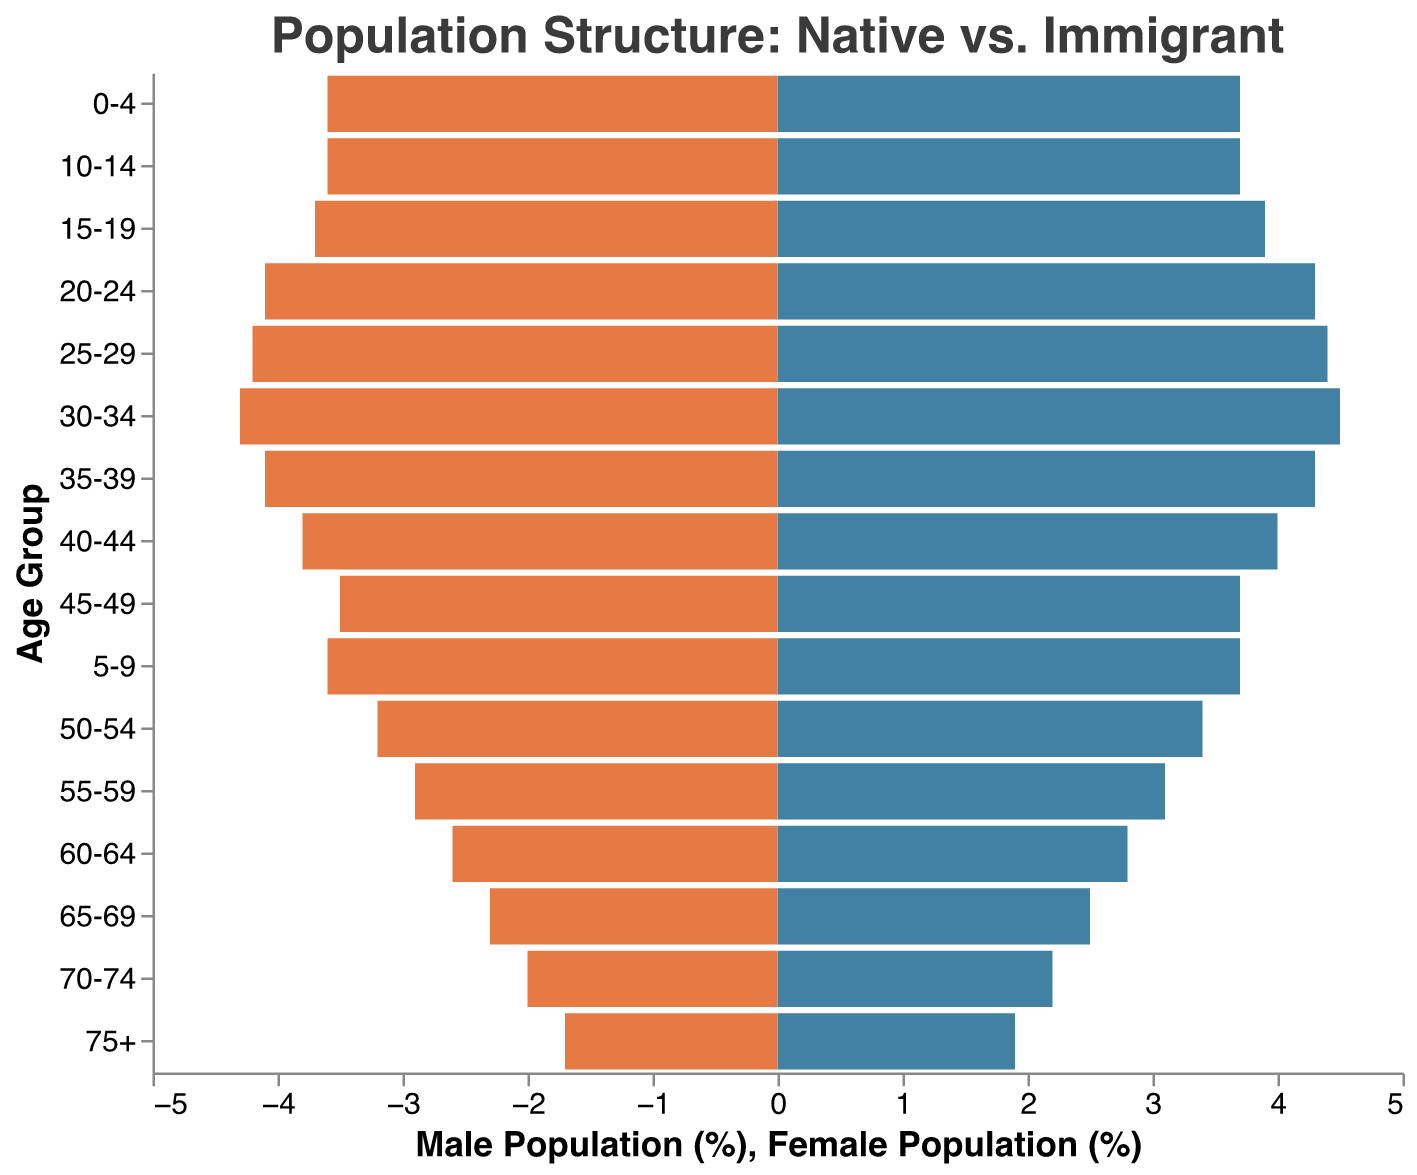what's the title of the figure? The title of the figure is displayed at the top of the plot in a larger font. It reads "Population Structure: Native vs. Immigrant".
Answer: Population Structure: Native vs. Immigrant what is the age group with the highest proportion of native males? By observing the bars on the left for native males, the group with the largest bar is labeled "0-4". The height is roughly 3.2%.
Answer: 0-4 which age group has the smallest proportion of immigrant females? Among the bars on the left for immigrant females, the group with the smallest bar is labeled "75+". The height is roughly 0.5%.
Answer: 75+ what's the combined size of the 30-34 age group (native female + immigrant female)? From the figure's data, the native female percentage for 30-34 is 2.1%, and the immigrant female percentage is 2.2%. Adding them produces 2.1 + 2.2 = 4.3%.
Answer: 4.3% is the population of immigrants aged 20-24 greater than that of the 40-44 age group? The bars for immigrants aged 20-24 (both male and female) sum up to 1.8% (male) + 1.7% (female) = 3.5%. Meanwhile, the bars for immigrants aged 40-44 sum up to 2.0% (male) + 1.9% (female) = 3.9%. 3.5% is less than 3.9%.
Answer: No which age group has a greater male proportion compared to female: native or immigrant? For each age category, comparing native and immigrant populations: 
- Native: 0-4 (3.2 vs 3.1), 5-9 (3.0 vs 2.9), and so on
- Immigrant: 0-4 (0.5 vs 0.5), 5-9 (0.7 vs 0.7), and so on
Higher male proportions are seen in immigrants where most male percentages (like 15-19) are greater by 0.1-0.2.
Answer: Immigrant what's the combined proportion of native males and females for the age group 65-69? From the data, the native male percentage for 65-69 is 1.5%, and the native female percentage is 1.4%. Adding them together results in 1.5 + 1.4 = 2.9%.
Answer: 2.9% do native females aged 50-54 exceed immigrant females in the same range? Looking at the horizontal bars for native (1.7%) and immigrants (1.5%). Since 1.7% is greater than 1.5%, the answer is yes.
Answer: Yes between ages 25-29 inclusion, is the immigrant female percentage larger than the native female percentage? The immigrant female percentage is 2.0% and native female percentage is 2.2%. Since 2.0% isn't greater than 2.2%, the answer is no.
Answer: No what percentage is added from native and immigrant males aged 15-19? Adding 2.7% native male plus 1.2% immigrant male equals 3.9%.
Answer: 3.9% 